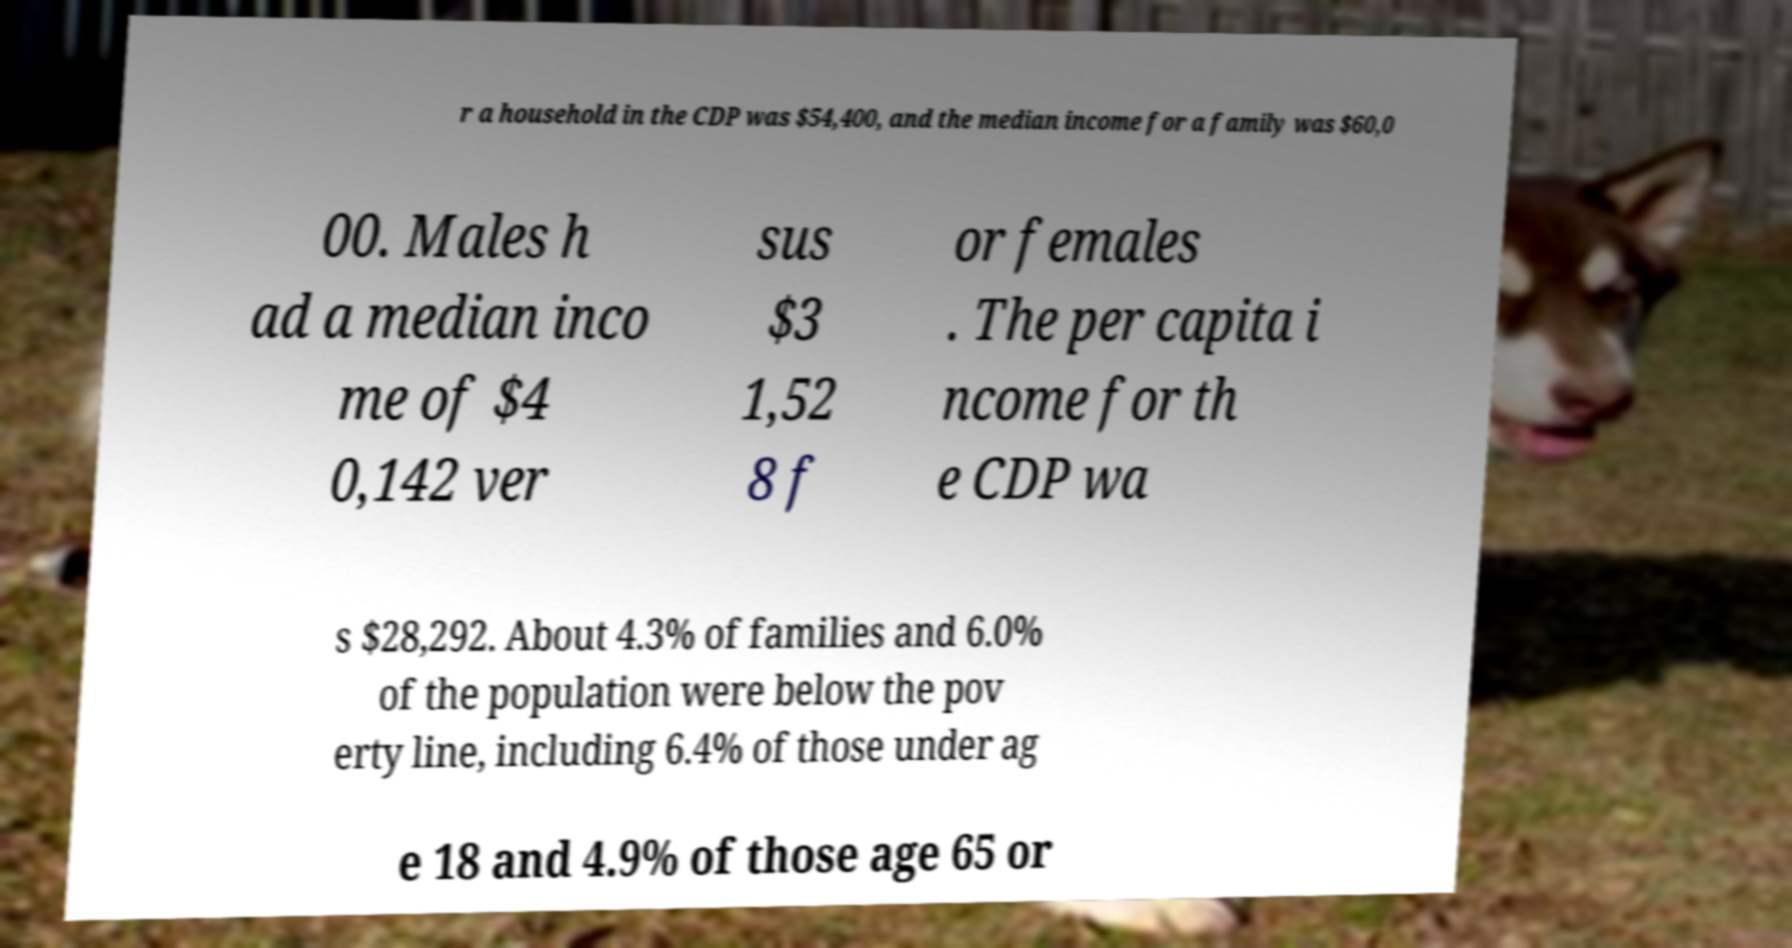There's text embedded in this image that I need extracted. Can you transcribe it verbatim? r a household in the CDP was $54,400, and the median income for a family was $60,0 00. Males h ad a median inco me of $4 0,142 ver sus $3 1,52 8 f or females . The per capita i ncome for th e CDP wa s $28,292. About 4.3% of families and 6.0% of the population were below the pov erty line, including 6.4% of those under ag e 18 and 4.9% of those age 65 or 